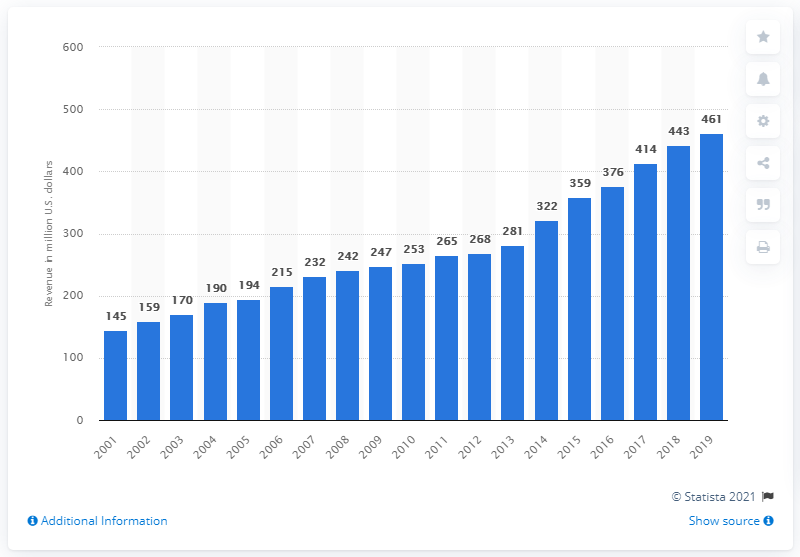List a handful of essential elements in this visual. The Miami Dolphins' revenue in 2019 was approximately $461 million. 